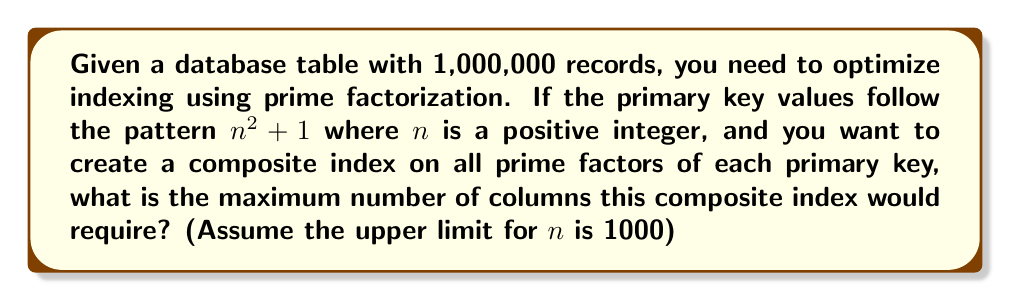Provide a solution to this math problem. Let's approach this step-by-step:

1) The pattern for primary keys is $n^2 + 1$, where $1 \leq n \leq 1000$.

2) The largest possible primary key value is when $n = 1000$:
   $1000^2 + 1 = 1,000,001$

3) We need to find the number of prime factors for the worst case scenario, which would be the number with the most prime factors in this range.

4) The number $n^2 + 1$ is known as a Fermat number when $n$ is a power of 2. These numbers are often prime or have large prime factors.

5) However, for our range, the number with the most prime factors is likely to be a highly composite number close to but not exceeding 1,000,001.

6) The highly composite number closest to 1,000,001 is 997,920 = $2^8 \times 3^4 \times 5 \times 7$.

7) This number has 14 prime factors when counting repeated factors:
   $2, 2, 2, 2, 2, 2, 2, 2, 3, 3, 3, 3, 5, 7$

8) Therefore, in the worst case, we would need 14 columns for our composite index to accommodate all prime factors of any primary key in our range.

This approach allows for efficient querying based on any combination of prime factors, which can be particularly useful for certain types of mathematical or scientific databases.
Answer: 14 